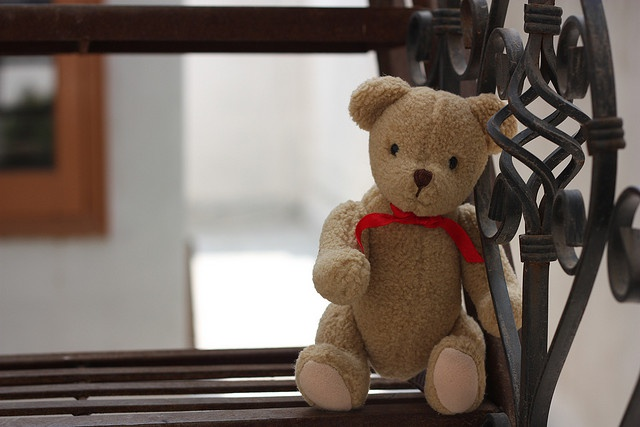Describe the objects in this image and their specific colors. I can see teddy bear in black, maroon, and gray tones and bench in black, gray, and darkgray tones in this image. 